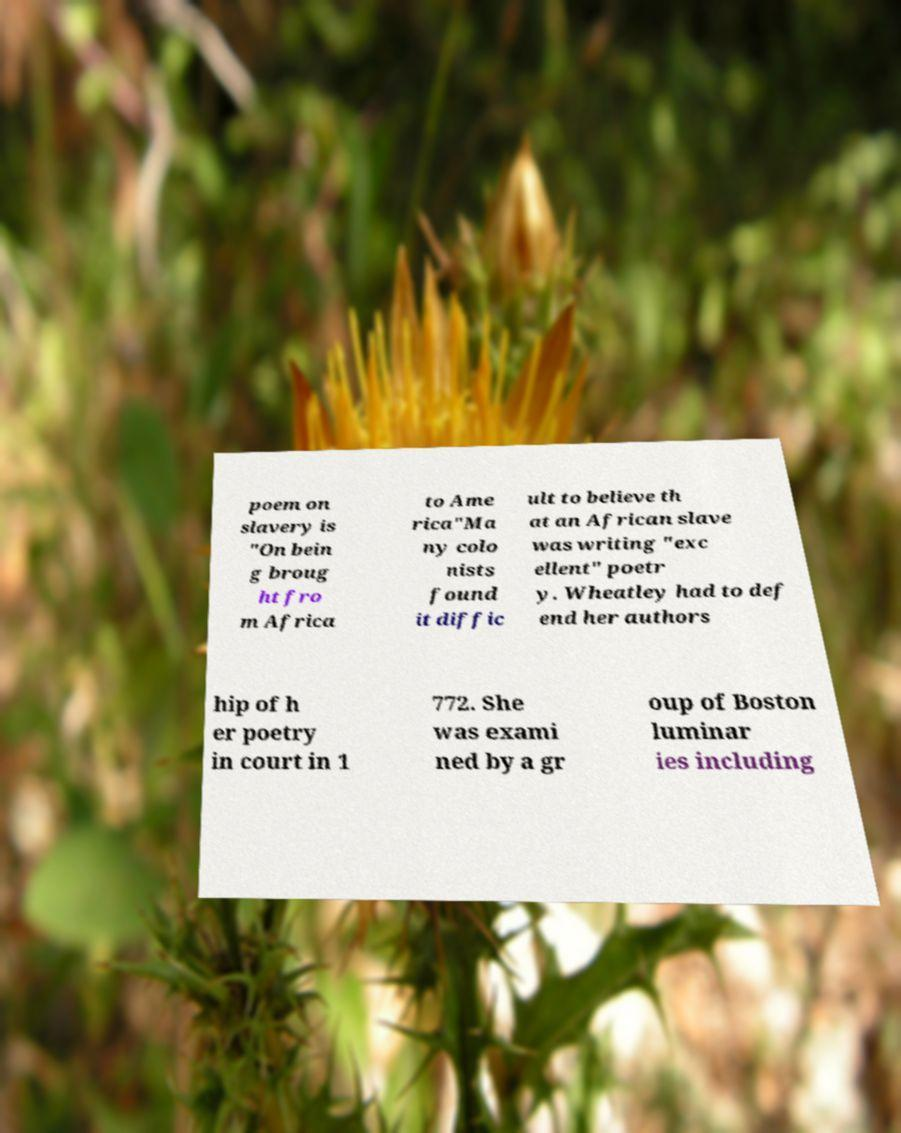Can you accurately transcribe the text from the provided image for me? poem on slavery is "On bein g broug ht fro m Africa to Ame rica"Ma ny colo nists found it diffic ult to believe th at an African slave was writing "exc ellent" poetr y. Wheatley had to def end her authors hip of h er poetry in court in 1 772. She was exami ned by a gr oup of Boston luminar ies including 